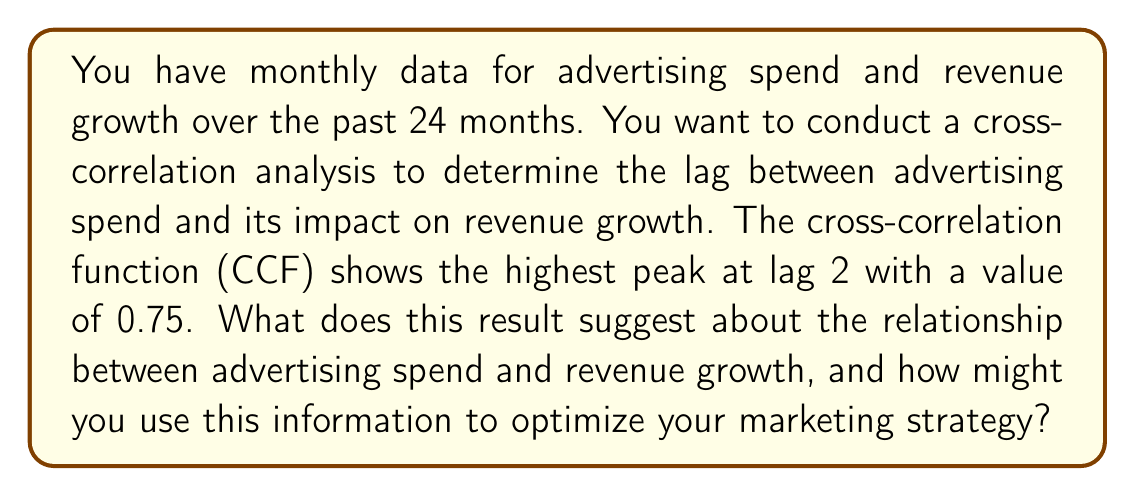Solve this math problem. To interpret this result, we need to understand the components of cross-correlation analysis:

1. Cross-correlation function (CCF): Measures the similarity between two time series as a function of the displacement of one relative to the other.

2. Lag: The time difference between the two series being compared.

3. CCF value: Ranges from -1 to 1, where 1 indicates perfect positive correlation, -1 indicates perfect negative correlation, and 0 indicates no correlation.

In this case:

$$\text{CCF}_{\text{max}} = 0.75 \text{ at lag } 2$$

This result suggests:

a) Positive correlation: The CCF value of 0.75 indicates a strong positive correlation between advertising spend and revenue growth.

b) Lag effect: The peak at lag 2 suggests that the impact of advertising spend on revenue growth is most significant after a 2-month delay.

c) Magnitude of impact: The correlation coefficient of 0.75 suggests that approximately 56.25% ($0.75^2 = 0.5625$) of the variation in revenue growth can be explained by variations in advertising spend, assuming a linear relationship.

To optimize the marketing strategy based on this information:

1. Budget allocation: Plan advertising budgets with a 2-month lead time before expected revenue growth periods.

2. Campaign duration: Design campaigns to run for at least 2 months to capture the full impact on revenue growth.

3. Performance measurement: When evaluating the effectiveness of advertising spend, look at revenue growth metrics 2 months after the spending occurs.

4. Forecasting: Use the 2-month lag in predictive models to forecast future revenue growth based on current advertising spend.

5. A/B testing: When testing new marketing strategies, allow for a 2-month observation period to accurately assess their impact on revenue growth.
Answer: The cross-correlation analysis suggests a strong positive relationship (CCF = 0.75) between advertising spend and revenue growth, with advertising spend having the most significant impact on revenue growth after a 2-month lag. This information can be used to optimize marketing strategies by planning advertising budgets 2 months in advance, designing campaigns to run for at least 2 months, evaluating performance after a 2-month delay, incorporating the lag into forecasting models, and allowing for a 2-month observation period in A/B testing of new marketing strategies. 